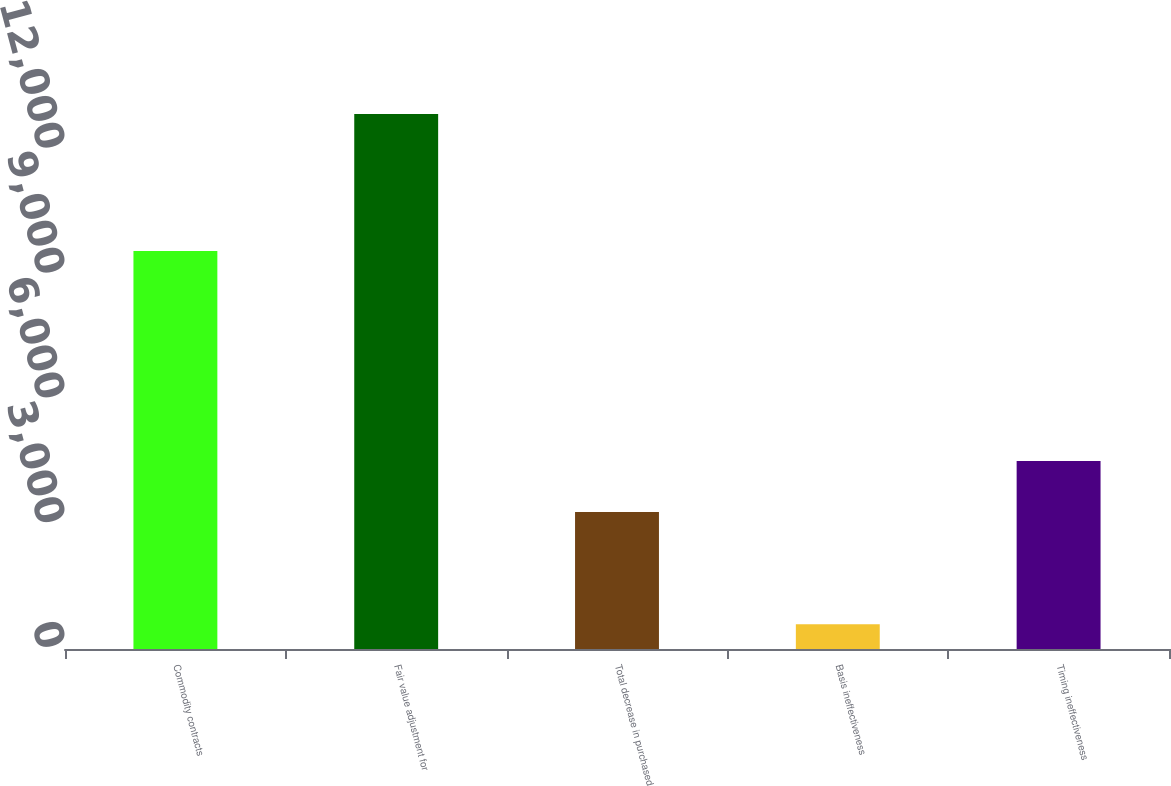<chart> <loc_0><loc_0><loc_500><loc_500><bar_chart><fcel>Commodity contracts<fcel>Fair value adjustment for<fcel>Total decrease in purchased<fcel>Basis ineffectiveness<fcel>Timing ineffectiveness<nl><fcel>9567<fcel>12858<fcel>3291<fcel>597<fcel>4517.1<nl></chart> 